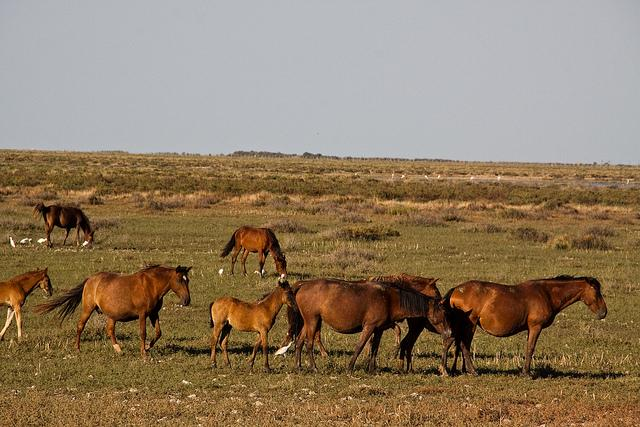What type of land are the horses found on?

Choices:
A) mountains
B) plains
C) hills
D) gulfs plains 